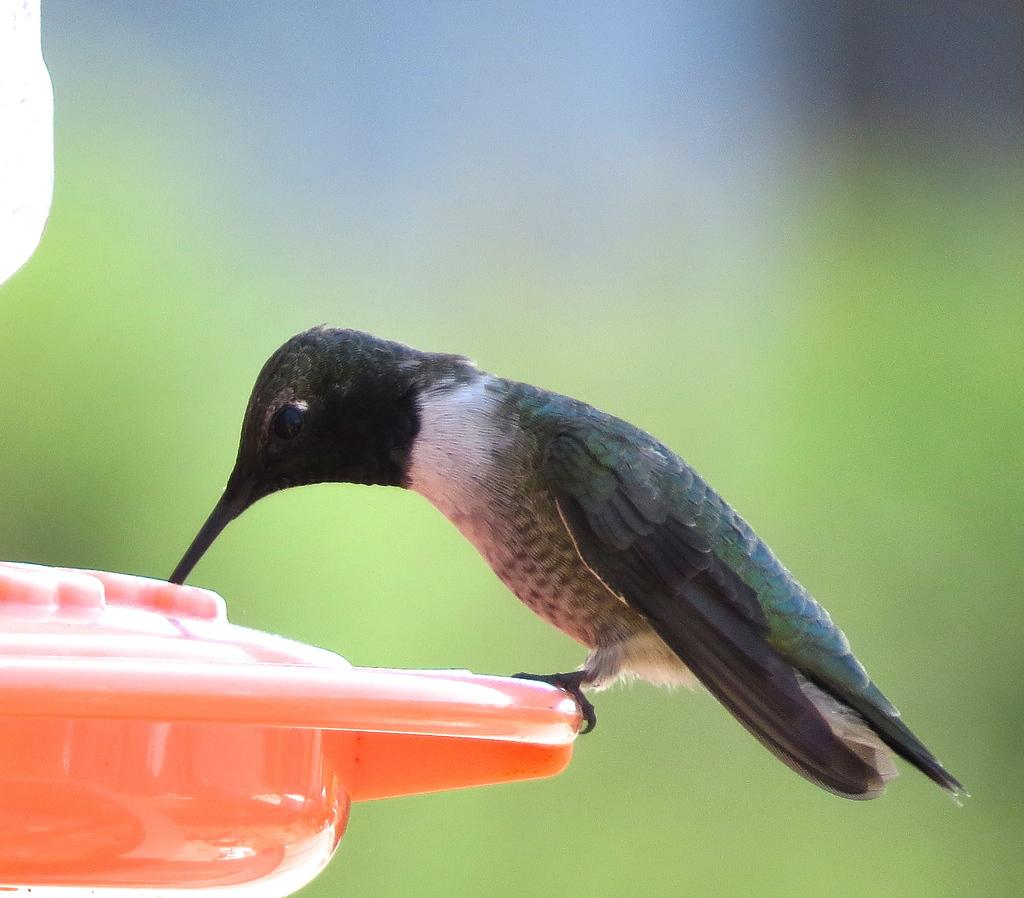What type of animal is in the image? There is a bird in the image. What is the bird sitting on? The bird is on an orange object. Can you describe the background of the image? The background of the image is blurry. How many trucks are visible in the image? There are no trucks visible in the image; it features a bird on an orange object with a blurry background. 